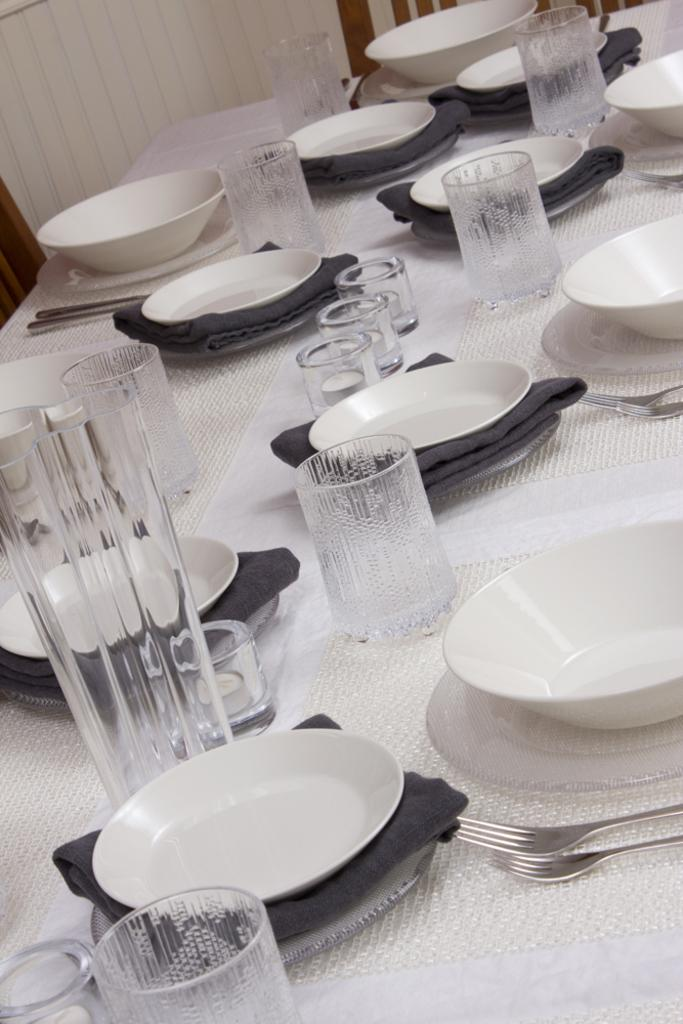What type of objects are present on the table in the image? There are glasses and a bowl on the table in the image. What is the purpose of the glasses and bowl? The purpose of the glasses and bowl is likely for serving food or drinks. Where is the table located in relation to other objects in the image? The table is located in front of a chair visible in the background of the image. What type of pain can be seen on the faces of the glasses in the image? There are no faces or expressions of pain on the glasses in the image, as they are inanimate objects. 